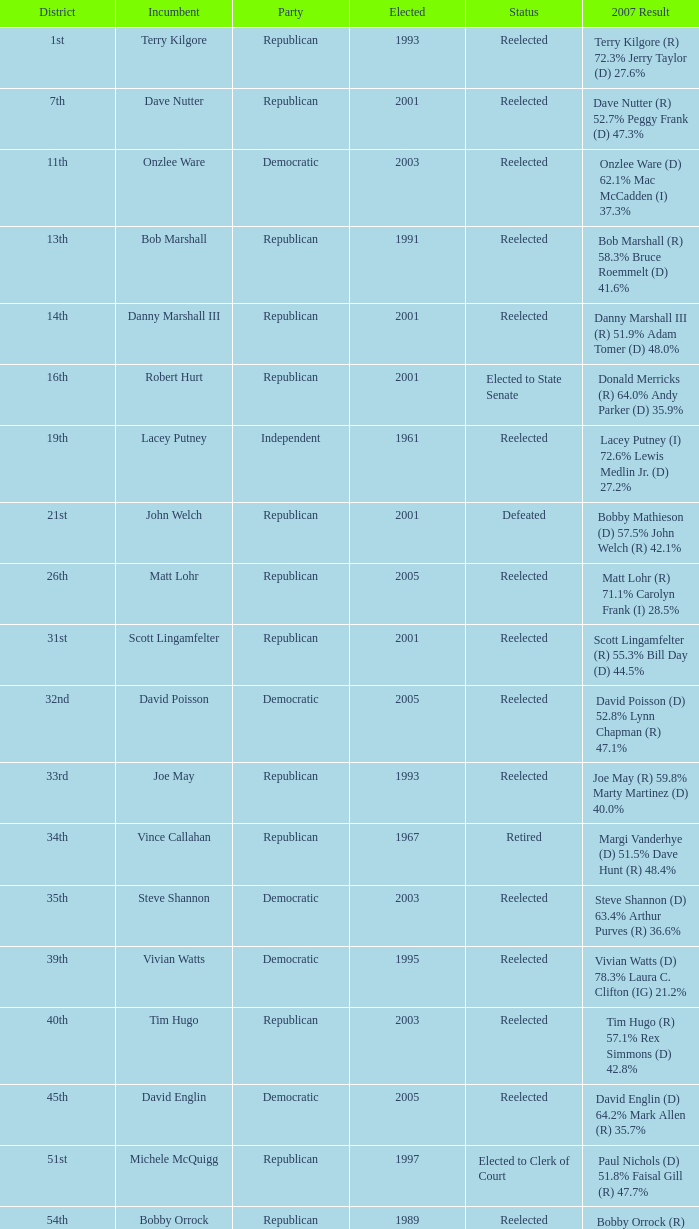How many times was incumbent onzlee ware elected? 1.0. 